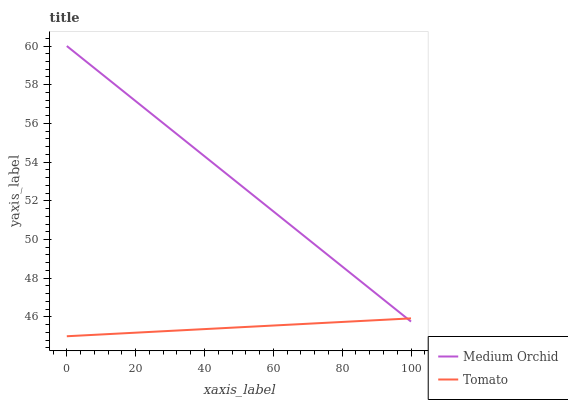Does Medium Orchid have the minimum area under the curve?
Answer yes or no. No. Is Medium Orchid the smoothest?
Answer yes or no. No. Does Medium Orchid have the lowest value?
Answer yes or no. No. 